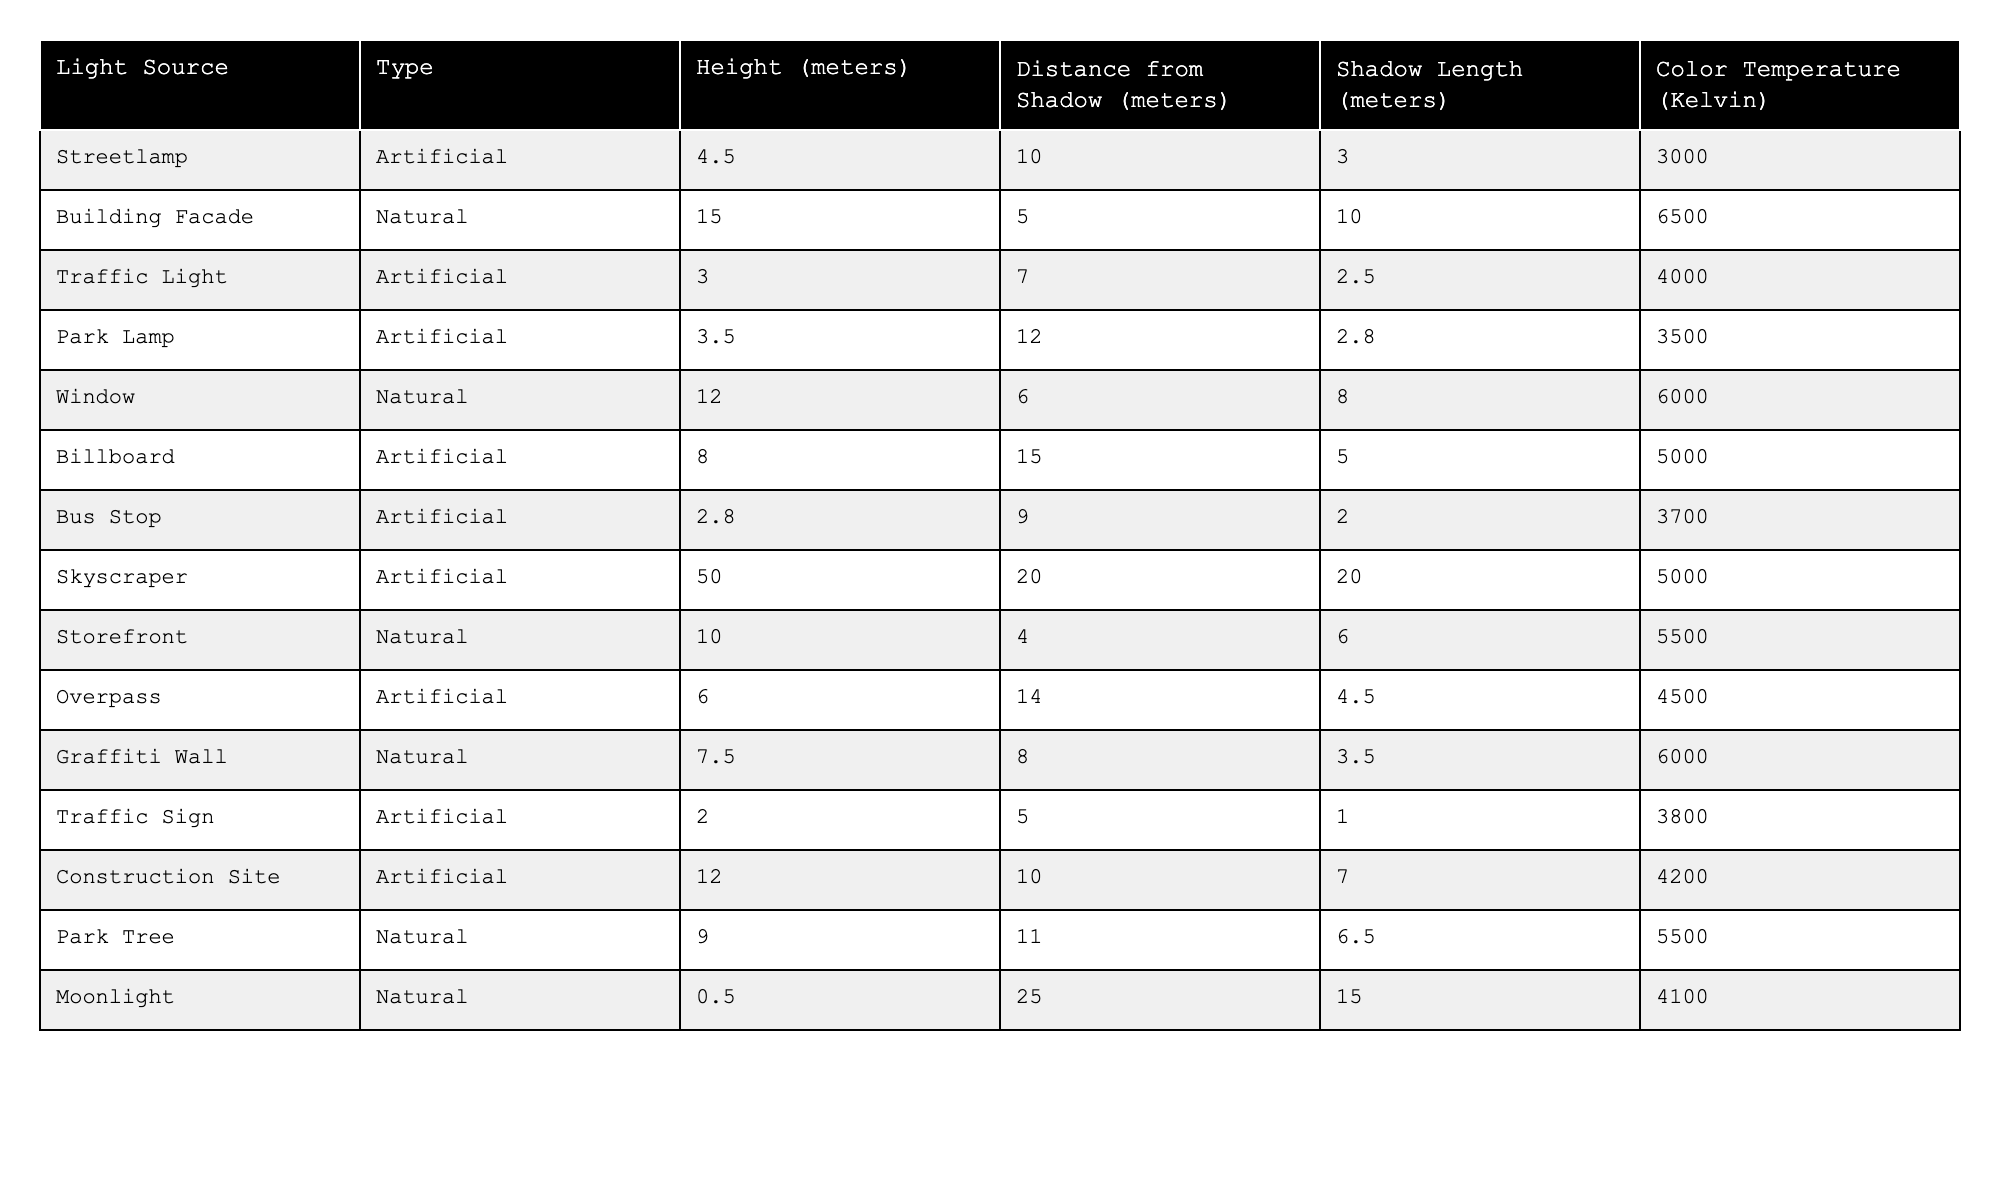What is the shadow length cast by the Skyscraper? The table lists the Skyscraper's shadow length under the "Shadow Length (meters)" column, which indicates it is 20.0 meters long.
Answer: 20.0 meters Which light source has the highest color temperature? By examining the "Color Temperature (Kelvin)" column in the table, the Building Facade has the highest value at 6500 Kelvin.
Answer: 6500 Kelvin Is the shadow length of the Traffic Sign longer than that of the Park Lamp? The shadow length of the Traffic Sign is 1.0 meters and the Park Lamp's shadow length is 2.8 meters. Since 1.0 meters is not longer than 2.8 meters, the answer is no.
Answer: No What is the average shadow length of the natural light sources? The natural light sources and their shadow lengths are: Building Facade (10.0 m), Window (8.0 m), Storefront (6.0 m), Park Tree (6.5 m), and Moonlight (15.0 m). The sum is (10.0 + 8.0 + 6.0 + 6.5 + 15.0) = 45.5 meters. There are 5 sources, so the average is 45.5 / 5 = 9.1 meters.
Answer: 9.1 meters How far is the Streetlamp from the object casting its shadow? The distance from the Streetlamp is listed in the "Distance from Shadow (meters)" column as 10 meters.
Answer: 10 meters Which artificial light source is closest to its shadow? By comparing the "Distance from Shadow (meters)" for artificial light sources in the table, the Bus Stop is the closest at a distance of 9 meters.
Answer: Bus Stop What is the combined shadow length of all artificial light sources? The shadow lengths for the artificial sources are: Streetlamp (3.0 m), Traffic Light (2.5 m), Park Lamp (2.8 m), Billboard (5.0 m), Skyscraper (20.0 m), Bus Stop (2.0 m), Overpass (4.5 m), Construction Site (7.0 m). The sum is (3.0 + 2.5 + 2.8 + 5.0 + 20.0 + 2.0 + 4.5 + 7.0) = 47.8 meters.
Answer: 47.8 meters Is there any natural light source with a shadow longer than 10 meters? By reviewing the "Shadow Length (meters)" for natural light sources, only the Moonlight has a shadow length of 15.0 meters, which is longer than 10. Therefore, yes, there is one.
Answer: Yes Which light source has the shortest distance from the shadow? The table shows that the Traffic Sign has the shortest distance at 5 meters.
Answer: Traffic Sign What is the difference in height between the tallest light source and the shortest? The tallest light source is the Skyscraper at 50 meters and the shortest is the Traffic Sign at 2.0 meters. The difference is 50 - 2 = 48 meters.
Answer: 48 meters 